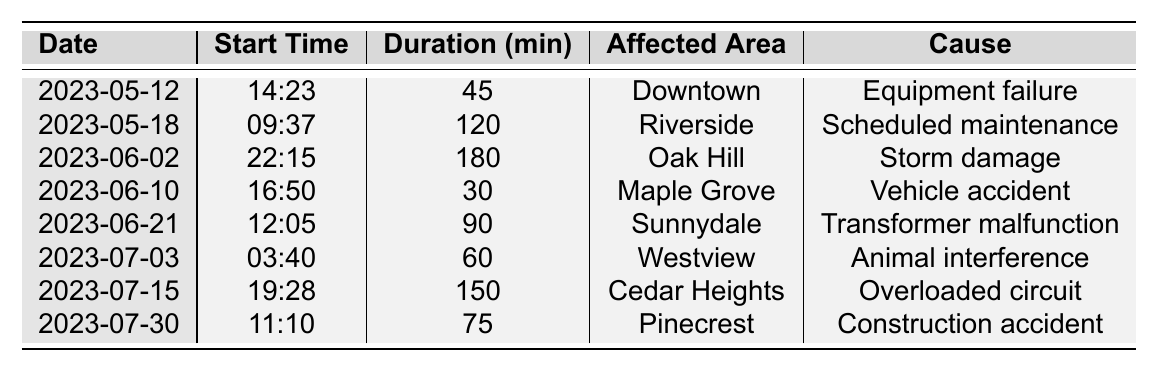What area was affected by the power outage on June 2, 2023? The table lists "Oak Hill" as the affected area for the outage on June 2, 2023.
Answer: Oak Hill How long did the power outage last in Riverside on May 18, 2023? According to the table, the duration of the outage in Riverside is stated as 120 minutes.
Answer: 120 minutes Was the cause of the power outage in Cedar Heights an overloaded circuit? The table indicates that the cause of the power outage in Cedar Heights was indeed "Overloaded circuit," which confirms the statement as true.
Answer: Yes Which power outage lasted the longest and what was its duration? By examining the durations in the table, the longest outage is on June 2, 2023, lasting 180 minutes due to storm damage.
Answer: 180 minutes How many outages were caused by accidents, and what were their durations? On the table, there are two outages caused by accidents (Vehicle accident in Maple Grove and Construction accident in Pinecrest). Their durations are 30 minutes and 75 minutes, respectively, giving a total of 105 minutes.
Answer: 105 minutes What is the total duration of all recorded power outages? To find the total duration, sum all the durations from the table: 45 + 120 + 180 + 30 + 90 + 60 + 150 + 75 = 750 minutes.
Answer: 750 minutes In how many instances was equipment failure the cause of a power outage? The table only lists one instance of equipment failure, which occurred on May 12, 2023, in Downtown.
Answer: 1 instance What was the average duration of the power outages listed in the table? To calculate the average, sum all durations (750 minutes) and divide by the number of outages (8): 750/8 = 93.75 minutes.
Answer: 93.75 minutes 